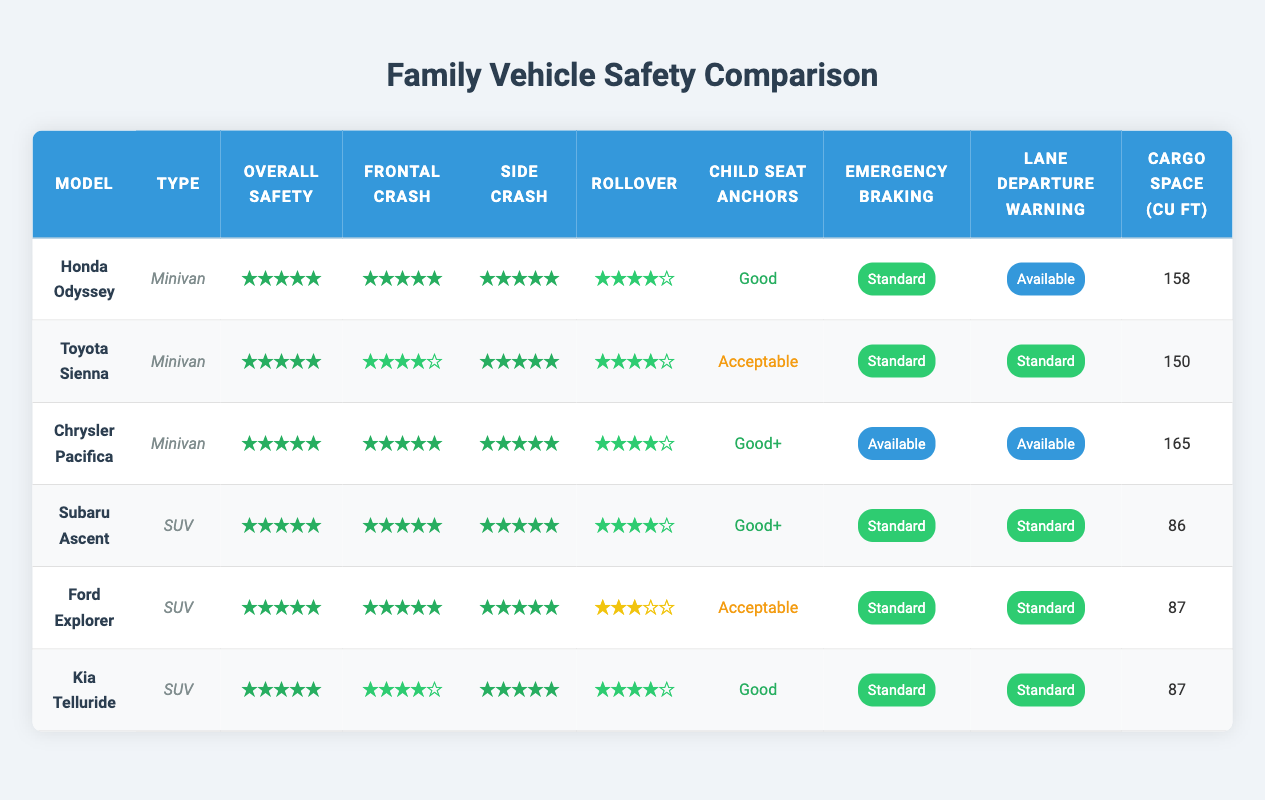What is the overall safety rating of the Toyota Sienna? The overall safety rating for the Toyota Sienna can be found in the table under the "Overall Safety" column for that vehicle. It shows that the rating is 5.
Answer: 5 Which vehicle has the largest cargo space? The table lists the cargo space for each vehicle in the "Cargo Space (cu ft)" column. By comparing the values, the Chrysler Pacifica has the largest cargo space at 165 cubic feet.
Answer: Chrysler Pacifica Do all vehicles have a side crash rating of 5? To answer this, we check the "Side Crash" column for each vehicle. The Ford Explorer has a side crash rating of 5, while the Toyota Sienna and Ford Explorer also have a rating of 5, but the ratings vary across others. Therefore, not all vehicles have a side crash rating of 5.
Answer: No What is the difference in cargo space between the Honda Odyssey and the Subaru Ascent? The cargo space for the Honda Odyssey is 158 cubic feet, while the cargo space for the Subaru Ascent is 86 cubic feet. Calculating the difference: 158 - 86 = 72 cubic feet.
Answer: 72 Which SUV has the best rollover rating? The rollover ratings can be found in the "Rollover" column of the SUV vehicles. By checking the table, both the Subaru Ascent and the Kia Telluride have a rollover rating of 4, which is the highest among the SUVs listed.
Answer: Subaru Ascent and Kia Telluride Does the Ford Explorer have emergency braking as a standard feature? Looking in the "Emergency Braking" column for the Ford Explorer, it shows "Standard." Therefore, it does have emergency braking as a standard feature.
Answer: Yes Which vehicle has the highest-rated child seat anchors? The child seat anchors ratings can be located in the "Child Seat Anchors" column. According to the table, the Chrysler Pacifica has the best rating with "Good+."
Answer: Chrysler Pacifica What is the average overall safety rating of the listed vehicles? All listed vehicles have an overall safety rating of 5. Since there are 6 vehicles, the average safety rating would be: (5 + 5 + 5 + 5 + 5 + 5) / 6 = 5.
Answer: 5 